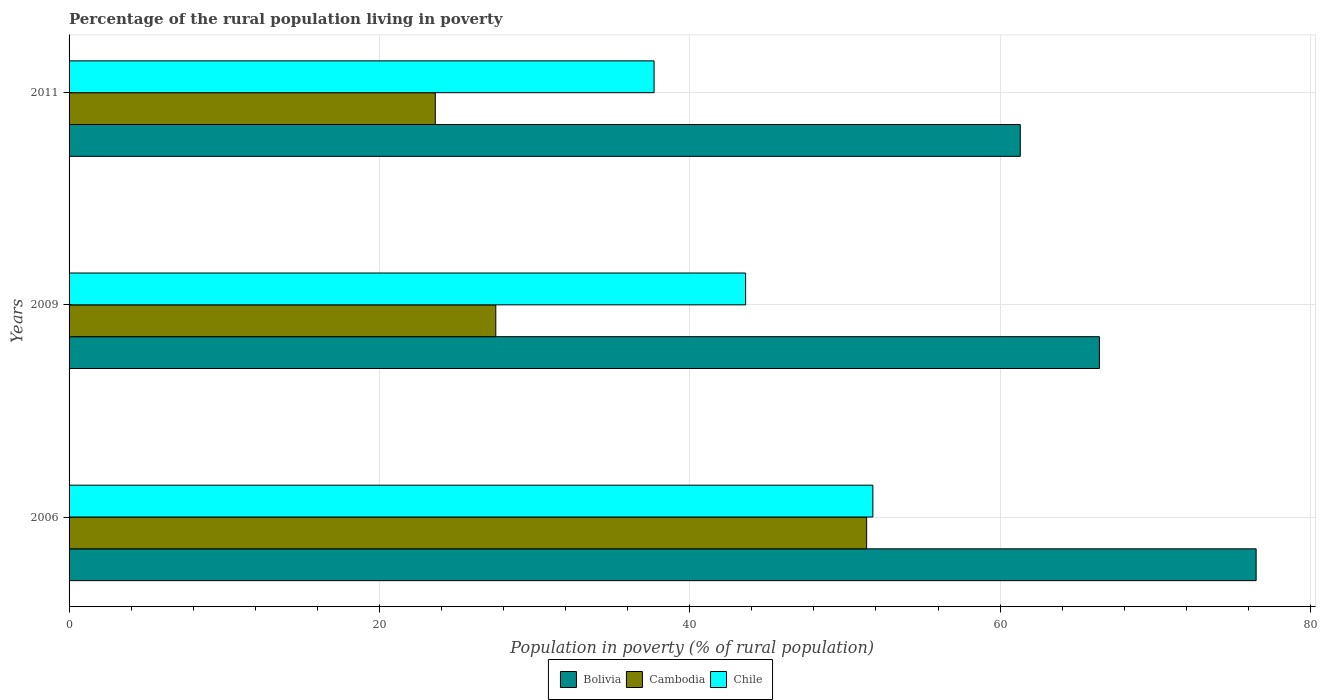How many different coloured bars are there?
Give a very brief answer. 3. How many groups of bars are there?
Keep it short and to the point. 3. How many bars are there on the 3rd tick from the bottom?
Offer a very short reply. 3. What is the label of the 1st group of bars from the top?
Your answer should be very brief. 2011. What is the percentage of the rural population living in poverty in Chile in 2006?
Ensure brevity in your answer.  51.8. Across all years, what is the maximum percentage of the rural population living in poverty in Chile?
Keep it short and to the point. 51.8. Across all years, what is the minimum percentage of the rural population living in poverty in Cambodia?
Provide a succinct answer. 23.6. What is the total percentage of the rural population living in poverty in Bolivia in the graph?
Ensure brevity in your answer.  204.2. What is the difference between the percentage of the rural population living in poverty in Bolivia in 2009 and that in 2011?
Keep it short and to the point. 5.1. What is the difference between the percentage of the rural population living in poverty in Chile in 2006 and the percentage of the rural population living in poverty in Cambodia in 2009?
Offer a very short reply. 24.3. What is the average percentage of the rural population living in poverty in Cambodia per year?
Make the answer very short. 34.17. In the year 2006, what is the difference between the percentage of the rural population living in poverty in Cambodia and percentage of the rural population living in poverty in Chile?
Your response must be concise. -0.4. What is the ratio of the percentage of the rural population living in poverty in Cambodia in 2009 to that in 2011?
Offer a very short reply. 1.17. Is the difference between the percentage of the rural population living in poverty in Cambodia in 2006 and 2011 greater than the difference between the percentage of the rural population living in poverty in Chile in 2006 and 2011?
Make the answer very short. Yes. What is the difference between the highest and the second highest percentage of the rural population living in poverty in Bolivia?
Your answer should be compact. 10.1. What is the difference between the highest and the lowest percentage of the rural population living in poverty in Bolivia?
Provide a short and direct response. 15.2. In how many years, is the percentage of the rural population living in poverty in Bolivia greater than the average percentage of the rural population living in poverty in Bolivia taken over all years?
Offer a terse response. 1. Is the sum of the percentage of the rural population living in poverty in Cambodia in 2006 and 2011 greater than the maximum percentage of the rural population living in poverty in Chile across all years?
Your response must be concise. Yes. What does the 2nd bar from the bottom in 2006 represents?
Make the answer very short. Cambodia. How many bars are there?
Offer a terse response. 9. Are all the bars in the graph horizontal?
Your answer should be compact. Yes. How many legend labels are there?
Ensure brevity in your answer.  3. How are the legend labels stacked?
Provide a short and direct response. Horizontal. What is the title of the graph?
Your answer should be very brief. Percentage of the rural population living in poverty. What is the label or title of the X-axis?
Offer a very short reply. Population in poverty (% of rural population). What is the label or title of the Y-axis?
Provide a succinct answer. Years. What is the Population in poverty (% of rural population) of Bolivia in 2006?
Your answer should be very brief. 76.5. What is the Population in poverty (% of rural population) of Cambodia in 2006?
Make the answer very short. 51.4. What is the Population in poverty (% of rural population) in Chile in 2006?
Your answer should be very brief. 51.8. What is the Population in poverty (% of rural population) of Bolivia in 2009?
Make the answer very short. 66.4. What is the Population in poverty (% of rural population) of Chile in 2009?
Your response must be concise. 43.6. What is the Population in poverty (% of rural population) of Bolivia in 2011?
Ensure brevity in your answer.  61.3. What is the Population in poverty (% of rural population) of Cambodia in 2011?
Keep it short and to the point. 23.6. What is the Population in poverty (% of rural population) of Chile in 2011?
Your answer should be compact. 37.7. Across all years, what is the maximum Population in poverty (% of rural population) in Bolivia?
Give a very brief answer. 76.5. Across all years, what is the maximum Population in poverty (% of rural population) in Cambodia?
Offer a very short reply. 51.4. Across all years, what is the maximum Population in poverty (% of rural population) in Chile?
Provide a succinct answer. 51.8. Across all years, what is the minimum Population in poverty (% of rural population) of Bolivia?
Provide a short and direct response. 61.3. Across all years, what is the minimum Population in poverty (% of rural population) of Cambodia?
Your response must be concise. 23.6. Across all years, what is the minimum Population in poverty (% of rural population) of Chile?
Offer a very short reply. 37.7. What is the total Population in poverty (% of rural population) of Bolivia in the graph?
Provide a succinct answer. 204.2. What is the total Population in poverty (% of rural population) in Cambodia in the graph?
Your answer should be compact. 102.5. What is the total Population in poverty (% of rural population) in Chile in the graph?
Provide a succinct answer. 133.1. What is the difference between the Population in poverty (% of rural population) in Bolivia in 2006 and that in 2009?
Ensure brevity in your answer.  10.1. What is the difference between the Population in poverty (% of rural population) of Cambodia in 2006 and that in 2009?
Provide a short and direct response. 23.9. What is the difference between the Population in poverty (% of rural population) of Bolivia in 2006 and that in 2011?
Provide a succinct answer. 15.2. What is the difference between the Population in poverty (% of rural population) of Cambodia in 2006 and that in 2011?
Keep it short and to the point. 27.8. What is the difference between the Population in poverty (% of rural population) of Chile in 2006 and that in 2011?
Provide a short and direct response. 14.1. What is the difference between the Population in poverty (% of rural population) of Bolivia in 2009 and that in 2011?
Ensure brevity in your answer.  5.1. What is the difference between the Population in poverty (% of rural population) of Chile in 2009 and that in 2011?
Make the answer very short. 5.9. What is the difference between the Population in poverty (% of rural population) in Bolivia in 2006 and the Population in poverty (% of rural population) in Cambodia in 2009?
Provide a short and direct response. 49. What is the difference between the Population in poverty (% of rural population) in Bolivia in 2006 and the Population in poverty (% of rural population) in Chile in 2009?
Your answer should be very brief. 32.9. What is the difference between the Population in poverty (% of rural population) of Cambodia in 2006 and the Population in poverty (% of rural population) of Chile in 2009?
Provide a short and direct response. 7.8. What is the difference between the Population in poverty (% of rural population) of Bolivia in 2006 and the Population in poverty (% of rural population) of Cambodia in 2011?
Provide a short and direct response. 52.9. What is the difference between the Population in poverty (% of rural population) of Bolivia in 2006 and the Population in poverty (% of rural population) of Chile in 2011?
Make the answer very short. 38.8. What is the difference between the Population in poverty (% of rural population) in Bolivia in 2009 and the Population in poverty (% of rural population) in Cambodia in 2011?
Keep it short and to the point. 42.8. What is the difference between the Population in poverty (% of rural population) in Bolivia in 2009 and the Population in poverty (% of rural population) in Chile in 2011?
Your answer should be very brief. 28.7. What is the average Population in poverty (% of rural population) of Bolivia per year?
Ensure brevity in your answer.  68.07. What is the average Population in poverty (% of rural population) of Cambodia per year?
Offer a very short reply. 34.17. What is the average Population in poverty (% of rural population) in Chile per year?
Provide a succinct answer. 44.37. In the year 2006, what is the difference between the Population in poverty (% of rural population) in Bolivia and Population in poverty (% of rural population) in Cambodia?
Ensure brevity in your answer.  25.1. In the year 2006, what is the difference between the Population in poverty (% of rural population) of Bolivia and Population in poverty (% of rural population) of Chile?
Your answer should be very brief. 24.7. In the year 2006, what is the difference between the Population in poverty (% of rural population) of Cambodia and Population in poverty (% of rural population) of Chile?
Provide a short and direct response. -0.4. In the year 2009, what is the difference between the Population in poverty (% of rural population) of Bolivia and Population in poverty (% of rural population) of Cambodia?
Ensure brevity in your answer.  38.9. In the year 2009, what is the difference between the Population in poverty (% of rural population) in Bolivia and Population in poverty (% of rural population) in Chile?
Offer a terse response. 22.8. In the year 2009, what is the difference between the Population in poverty (% of rural population) in Cambodia and Population in poverty (% of rural population) in Chile?
Offer a very short reply. -16.1. In the year 2011, what is the difference between the Population in poverty (% of rural population) in Bolivia and Population in poverty (% of rural population) in Cambodia?
Give a very brief answer. 37.7. In the year 2011, what is the difference between the Population in poverty (% of rural population) in Bolivia and Population in poverty (% of rural population) in Chile?
Ensure brevity in your answer.  23.6. In the year 2011, what is the difference between the Population in poverty (% of rural population) of Cambodia and Population in poverty (% of rural population) of Chile?
Provide a succinct answer. -14.1. What is the ratio of the Population in poverty (% of rural population) of Bolivia in 2006 to that in 2009?
Your answer should be very brief. 1.15. What is the ratio of the Population in poverty (% of rural population) of Cambodia in 2006 to that in 2009?
Keep it short and to the point. 1.87. What is the ratio of the Population in poverty (% of rural population) of Chile in 2006 to that in 2009?
Offer a very short reply. 1.19. What is the ratio of the Population in poverty (% of rural population) of Bolivia in 2006 to that in 2011?
Offer a terse response. 1.25. What is the ratio of the Population in poverty (% of rural population) of Cambodia in 2006 to that in 2011?
Your answer should be very brief. 2.18. What is the ratio of the Population in poverty (% of rural population) in Chile in 2006 to that in 2011?
Make the answer very short. 1.37. What is the ratio of the Population in poverty (% of rural population) of Bolivia in 2009 to that in 2011?
Keep it short and to the point. 1.08. What is the ratio of the Population in poverty (% of rural population) in Cambodia in 2009 to that in 2011?
Your answer should be very brief. 1.17. What is the ratio of the Population in poverty (% of rural population) in Chile in 2009 to that in 2011?
Make the answer very short. 1.16. What is the difference between the highest and the second highest Population in poverty (% of rural population) of Bolivia?
Make the answer very short. 10.1. What is the difference between the highest and the second highest Population in poverty (% of rural population) of Cambodia?
Your response must be concise. 23.9. What is the difference between the highest and the lowest Population in poverty (% of rural population) in Cambodia?
Your response must be concise. 27.8. 